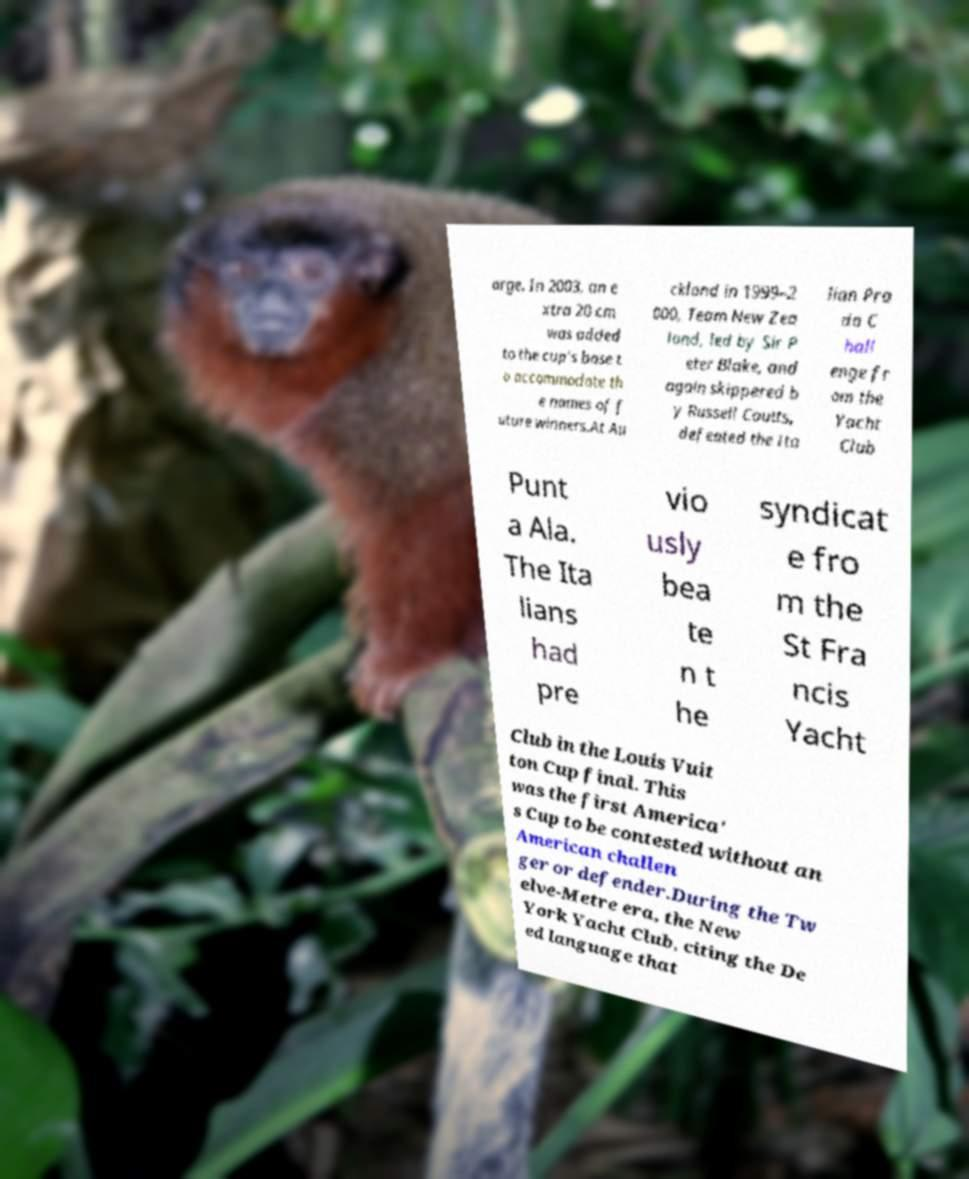For documentation purposes, I need the text within this image transcribed. Could you provide that? arge. In 2003, an e xtra 20 cm was added to the cup's base t o accommodate th e names of f uture winners.At Au ckland in 1999–2 000, Team New Zea land, led by Sir P eter Blake, and again skippered b y Russell Coutts, defeated the Ita lian Pra da C hall enge fr om the Yacht Club Punt a Ala. The Ita lians had pre vio usly bea te n t he syndicat e fro m the St Fra ncis Yacht Club in the Louis Vuit ton Cup final. This was the first America' s Cup to be contested without an American challen ger or defender.During the Tw elve-Metre era, the New York Yacht Club, citing the De ed language that 